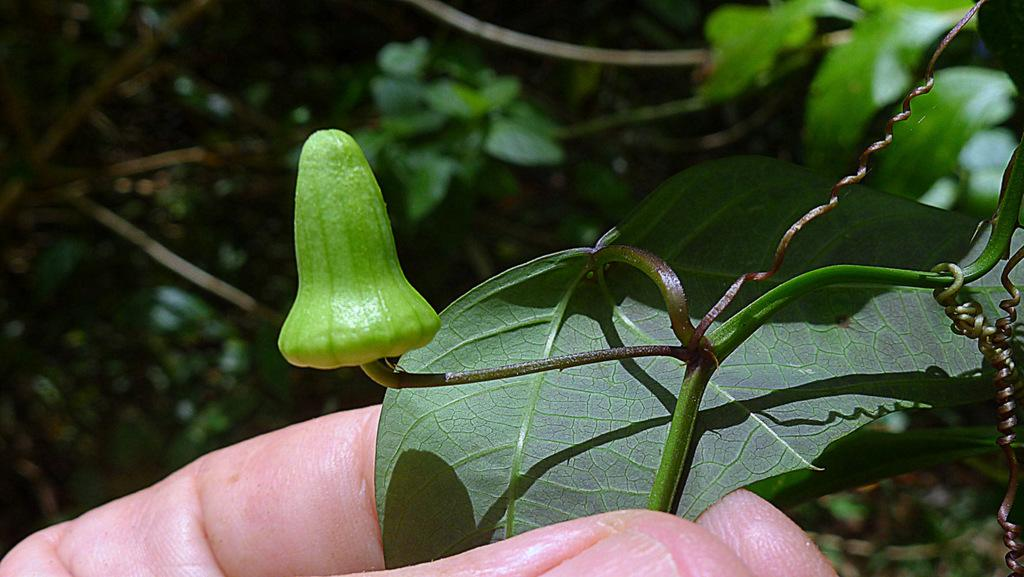What is the human hand holding in the image? The human hand is holding a plant leaf in the image. What part of the plant is visible in the image? There is a bud visible in the image. What type of vegetation can be seen in the image? There are trees on the side of the image. What type of nut is being used to wax the nose in the image? There is no nut, wax, or nose present in the image. 